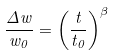Convert formula to latex. <formula><loc_0><loc_0><loc_500><loc_500>\frac { \Delta w } { w _ { 0 } } = \left ( \frac { t } { t _ { 0 } } \right ) ^ { \beta }</formula> 